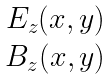Convert formula to latex. <formula><loc_0><loc_0><loc_500><loc_500>\begin{matrix} E _ { z } ( x , y ) \\ B _ { z } ( x , y ) \end{matrix}</formula> 